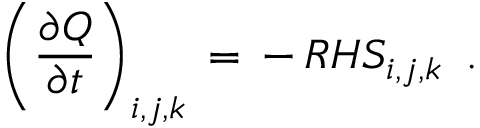Convert formula to latex. <formula><loc_0><loc_0><loc_500><loc_500>\left ( \frac { \partial Q } { \partial t } \right ) _ { i , j , k } \, = \, - \, R H S _ { i , j , k } \, .</formula> 